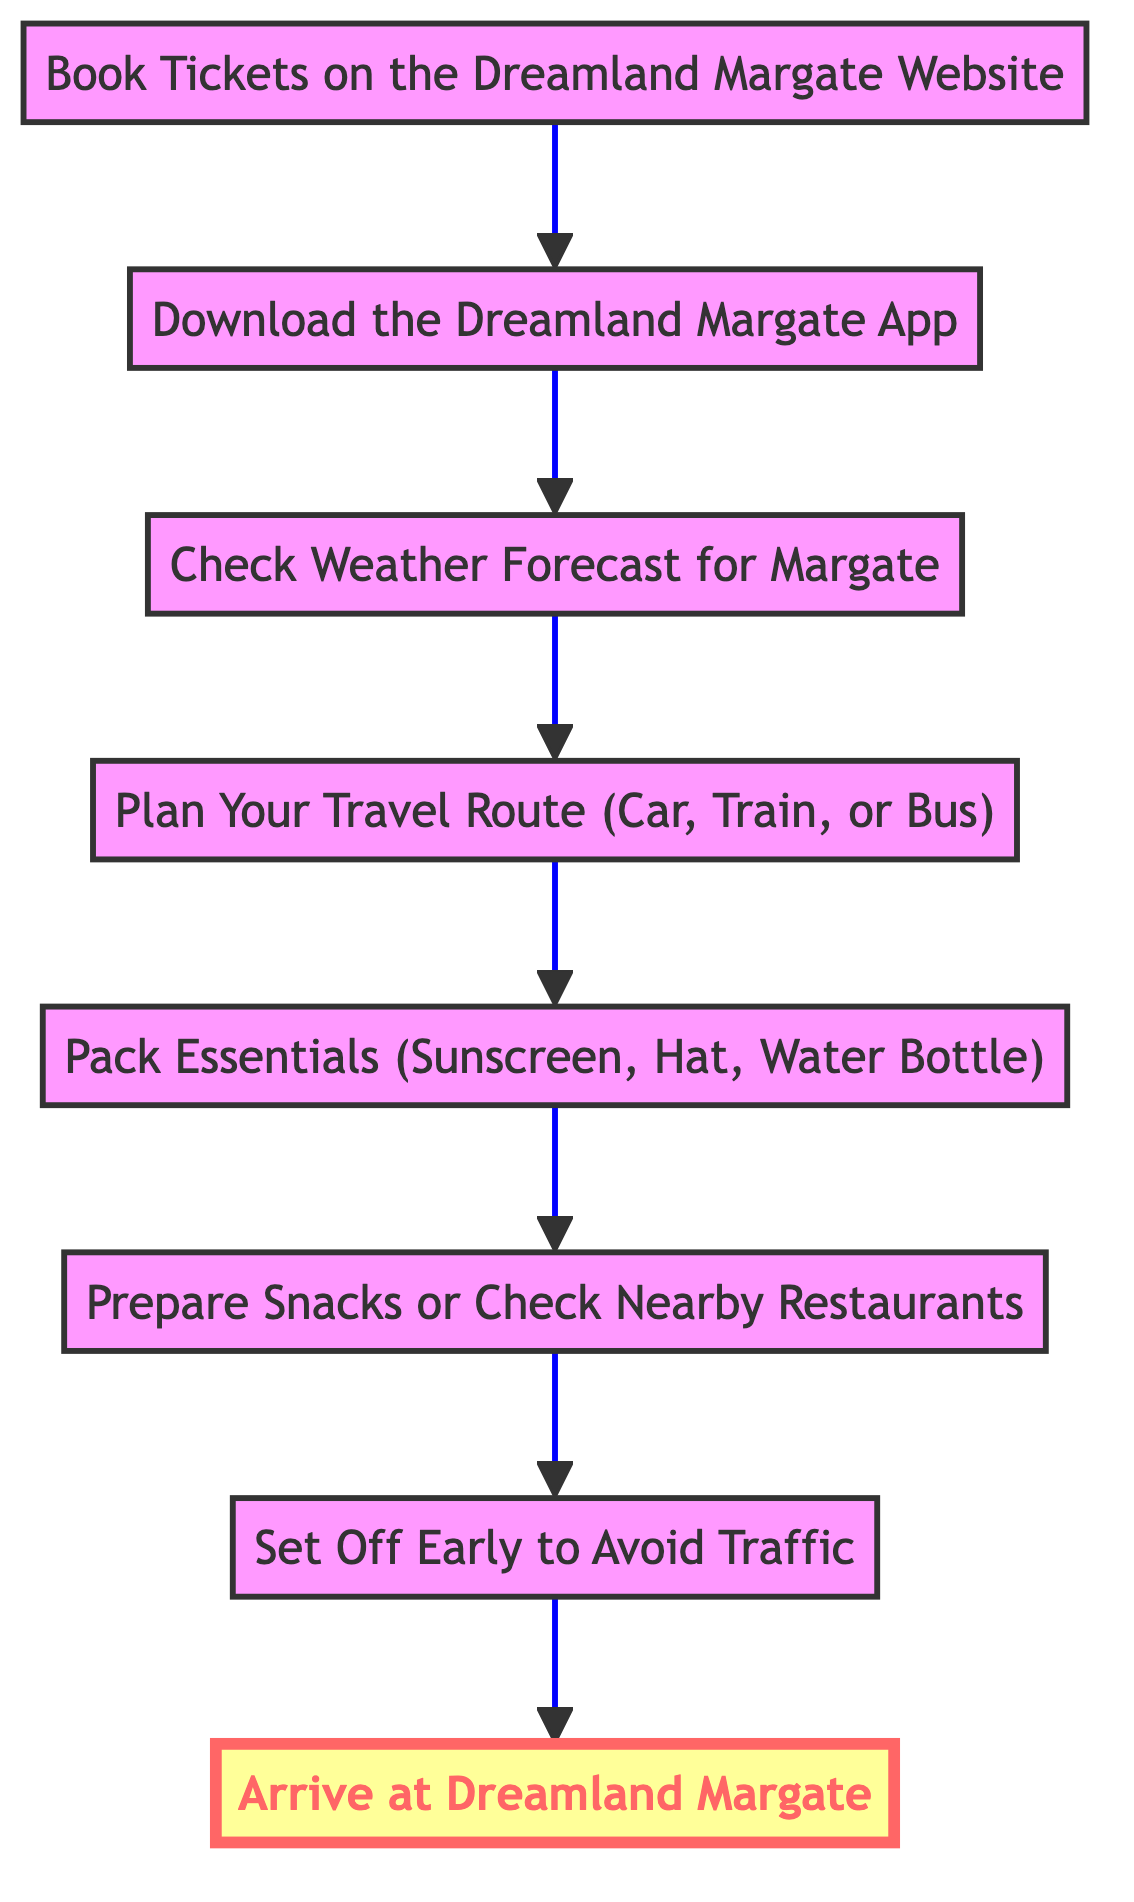What is the first step in planning a day trip to Dreamland Margate? The diagram indicates that the first step is "Book Tickets on the Dreamland Margate Website." It is the initial node at the bottom of the flowchart.
Answer: Book Tickets on the Dreamland Margate Website How many total steps are displayed in the diagram? The diagram has eight distinct steps listed from the bottom to the top. Counting each step from "Book Tickets" to "Arrive at Dreamland Margate," there are eight nodes in total.
Answer: 8 What comes after "Check Weather Forecast for Margate"? Following the node "Check Weather Forecast for Margate," the next step in the flowchart is "Plan Your Travel Route (Car, Train, or Bus)." This represents the continuation of planning activities.
Answer: Plan Your Travel Route (Car, Train, or Bus) What is the last step of planning a day trip to Dreamland Margate? The last step illustrated at the top of the flowchart is "Arrive at Dreamland Margate," indicating the final action to complete the trip planning.
Answer: Arrive at Dreamland Margate Which step involves preparing for travel essentials? The step that focuses on preparing travel essentials is "Pack Essentials (Sunscreen, Hat, Water Bottle)," which comes after planning the travel route.
Answer: Pack Essentials (Sunscreen, Hat, Water Bottle) What is the relationship between "Set Off Early to Avoid Traffic" and "Prepare Snacks or Check Nearby Restaurants"? According to the flowchart, "Prepare Snacks or Check Nearby Restaurants" must be completed before "Set Off Early to Avoid Traffic," illustrating the order of preparation leading to departure to avoid traffic delays.
Answer: Prepare Snacks or Check Nearby Restaurants → Set Off Early to Avoid Traffic What is the second step in the process? The second step listed in the diagram is "Download the Dreamland Margate App," which follows the initial step of booking tickets.
Answer: Download the Dreamland Margate App In how many steps do you have to prepare before arriving at Dreamland Margate? Before arriving at Dreamland Margate, there are six preparation steps: from downloading the app to setting off early, totaling six steps to prepare.
Answer: 6 